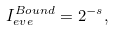Convert formula to latex. <formula><loc_0><loc_0><loc_500><loc_500>I _ { e v e } ^ { B o u n d } = 2 ^ { - s } ,</formula> 